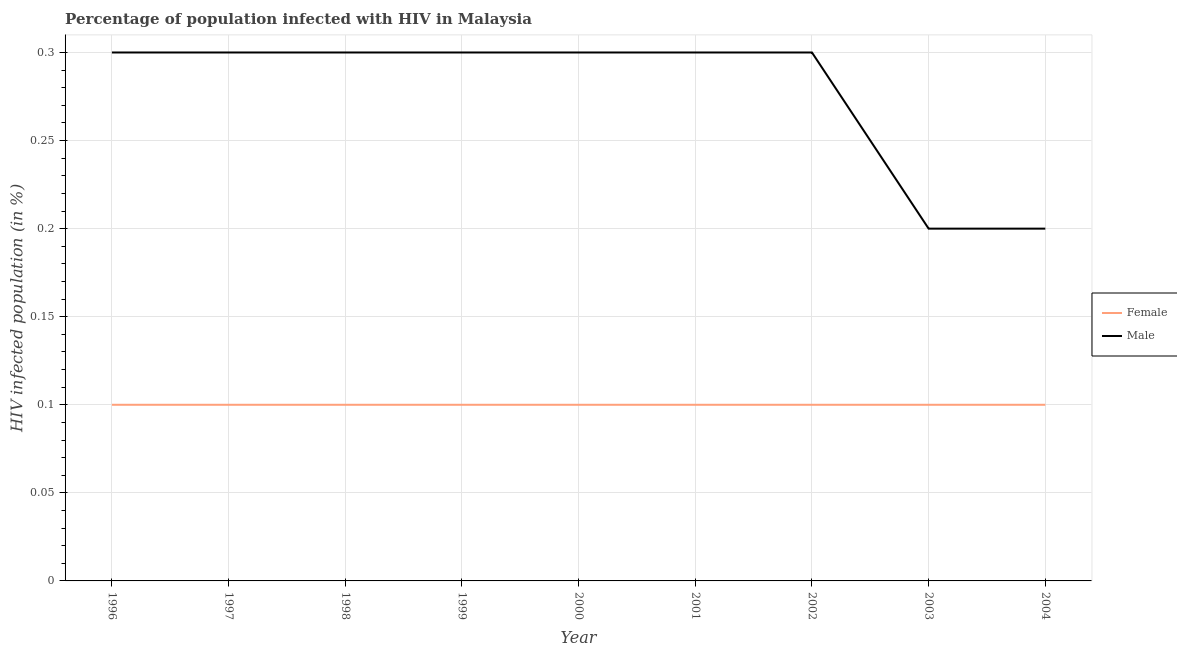How many different coloured lines are there?
Offer a terse response. 2. Across all years, what is the maximum percentage of males who are infected with hiv?
Keep it short and to the point. 0.3. What is the difference between the percentage of females who are infected with hiv in 1999 and that in 2002?
Provide a succinct answer. 0. What is the difference between the percentage of females who are infected with hiv in 1999 and the percentage of males who are infected with hiv in 2001?
Ensure brevity in your answer.  -0.2. What is the average percentage of females who are infected with hiv per year?
Provide a succinct answer. 0.1. In the year 2003, what is the difference between the percentage of females who are infected with hiv and percentage of males who are infected with hiv?
Offer a very short reply. -0.1. What is the ratio of the percentage of males who are infected with hiv in 2001 to that in 2004?
Give a very brief answer. 1.5. What is the difference between the highest and the second highest percentage of males who are infected with hiv?
Your answer should be very brief. 0. What is the difference between the highest and the lowest percentage of males who are infected with hiv?
Give a very brief answer. 0.1. In how many years, is the percentage of males who are infected with hiv greater than the average percentage of males who are infected with hiv taken over all years?
Offer a very short reply. 7. Is the sum of the percentage of females who are infected with hiv in 2001 and 2002 greater than the maximum percentage of males who are infected with hiv across all years?
Your response must be concise. No. Does the percentage of males who are infected with hiv monotonically increase over the years?
Offer a very short reply. No. Is the percentage of males who are infected with hiv strictly greater than the percentage of females who are infected with hiv over the years?
Your answer should be very brief. Yes. Is the percentage of males who are infected with hiv strictly less than the percentage of females who are infected with hiv over the years?
Offer a terse response. No. What is the difference between two consecutive major ticks on the Y-axis?
Give a very brief answer. 0.05. Are the values on the major ticks of Y-axis written in scientific E-notation?
Offer a very short reply. No. Does the graph contain any zero values?
Ensure brevity in your answer.  No. Does the graph contain grids?
Make the answer very short. Yes. What is the title of the graph?
Offer a terse response. Percentage of population infected with HIV in Malaysia. Does "Non-resident workers" appear as one of the legend labels in the graph?
Provide a succinct answer. No. What is the label or title of the Y-axis?
Ensure brevity in your answer.  HIV infected population (in %). What is the HIV infected population (in %) of Male in 1996?
Provide a short and direct response. 0.3. What is the HIV infected population (in %) of Female in 1999?
Your answer should be very brief. 0.1. What is the HIV infected population (in %) of Male in 1999?
Offer a very short reply. 0.3. What is the HIV infected population (in %) in Male in 2000?
Provide a short and direct response. 0.3. What is the HIV infected population (in %) of Female in 2001?
Ensure brevity in your answer.  0.1. What is the HIV infected population (in %) of Male in 2001?
Your response must be concise. 0.3. What is the HIV infected population (in %) in Female in 2002?
Give a very brief answer. 0.1. What is the HIV infected population (in %) of Female in 2003?
Give a very brief answer. 0.1. What is the HIV infected population (in %) in Male in 2003?
Make the answer very short. 0.2. What is the HIV infected population (in %) of Female in 2004?
Ensure brevity in your answer.  0.1. Across all years, what is the maximum HIV infected population (in %) in Male?
Offer a terse response. 0.3. Across all years, what is the minimum HIV infected population (in %) in Male?
Keep it short and to the point. 0.2. What is the total HIV infected population (in %) of Female in the graph?
Provide a short and direct response. 0.9. What is the difference between the HIV infected population (in %) in Female in 1996 and that in 1997?
Your response must be concise. 0. What is the difference between the HIV infected population (in %) in Female in 1996 and that in 1999?
Make the answer very short. 0. What is the difference between the HIV infected population (in %) in Male in 1996 and that in 2000?
Provide a short and direct response. 0. What is the difference between the HIV infected population (in %) in Male in 1996 and that in 2001?
Offer a terse response. 0. What is the difference between the HIV infected population (in %) in Female in 1996 and that in 2002?
Keep it short and to the point. 0. What is the difference between the HIV infected population (in %) of Male in 1996 and that in 2003?
Keep it short and to the point. 0.1. What is the difference between the HIV infected population (in %) of Male in 1996 and that in 2004?
Your answer should be very brief. 0.1. What is the difference between the HIV infected population (in %) in Female in 1997 and that in 1998?
Provide a succinct answer. 0. What is the difference between the HIV infected population (in %) of Male in 1997 and that in 1998?
Your answer should be compact. 0. What is the difference between the HIV infected population (in %) of Male in 1997 and that in 2000?
Your response must be concise. 0. What is the difference between the HIV infected population (in %) of Female in 1997 and that in 2001?
Your answer should be very brief. 0. What is the difference between the HIV infected population (in %) of Female in 1997 and that in 2003?
Make the answer very short. 0. What is the difference between the HIV infected population (in %) in Male in 1997 and that in 2003?
Provide a short and direct response. 0.1. What is the difference between the HIV infected population (in %) in Female in 1998 and that in 2000?
Ensure brevity in your answer.  0. What is the difference between the HIV infected population (in %) of Male in 1998 and that in 2002?
Provide a short and direct response. 0. What is the difference between the HIV infected population (in %) in Female in 1998 and that in 2004?
Offer a terse response. 0. What is the difference between the HIV infected population (in %) of Male in 1998 and that in 2004?
Provide a succinct answer. 0.1. What is the difference between the HIV infected population (in %) in Male in 1999 and that in 2000?
Offer a terse response. 0. What is the difference between the HIV infected population (in %) of Male in 1999 and that in 2001?
Your response must be concise. 0. What is the difference between the HIV infected population (in %) of Male in 1999 and that in 2003?
Keep it short and to the point. 0.1. What is the difference between the HIV infected population (in %) in Female in 1999 and that in 2004?
Your answer should be compact. 0. What is the difference between the HIV infected population (in %) in Male in 2000 and that in 2002?
Offer a terse response. 0. What is the difference between the HIV infected population (in %) in Male in 2000 and that in 2003?
Provide a succinct answer. 0.1. What is the difference between the HIV infected population (in %) in Female in 2000 and that in 2004?
Your answer should be very brief. 0. What is the difference between the HIV infected population (in %) in Male in 2000 and that in 2004?
Make the answer very short. 0.1. What is the difference between the HIV infected population (in %) of Female in 2001 and that in 2002?
Offer a very short reply. 0. What is the difference between the HIV infected population (in %) in Male in 2001 and that in 2002?
Provide a short and direct response. 0. What is the difference between the HIV infected population (in %) in Male in 2002 and that in 2003?
Your response must be concise. 0.1. What is the difference between the HIV infected population (in %) in Female in 2002 and that in 2004?
Offer a terse response. 0. What is the difference between the HIV infected population (in %) in Male in 2003 and that in 2004?
Ensure brevity in your answer.  0. What is the difference between the HIV infected population (in %) in Female in 1996 and the HIV infected population (in %) in Male in 2001?
Offer a very short reply. -0.2. What is the difference between the HIV infected population (in %) in Female in 1997 and the HIV infected population (in %) in Male in 2000?
Ensure brevity in your answer.  -0.2. What is the difference between the HIV infected population (in %) in Female in 1997 and the HIV infected population (in %) in Male in 2004?
Offer a terse response. -0.1. What is the difference between the HIV infected population (in %) in Female in 1998 and the HIV infected population (in %) in Male in 2000?
Your answer should be very brief. -0.2. What is the difference between the HIV infected population (in %) of Female in 1998 and the HIV infected population (in %) of Male in 2001?
Keep it short and to the point. -0.2. What is the difference between the HIV infected population (in %) of Female in 1998 and the HIV infected population (in %) of Male in 2002?
Ensure brevity in your answer.  -0.2. What is the difference between the HIV infected population (in %) of Female in 1998 and the HIV infected population (in %) of Male in 2003?
Provide a short and direct response. -0.1. What is the difference between the HIV infected population (in %) in Female in 1999 and the HIV infected population (in %) in Male in 2000?
Provide a succinct answer. -0.2. What is the difference between the HIV infected population (in %) of Female in 1999 and the HIV infected population (in %) of Male in 2004?
Offer a terse response. -0.1. What is the difference between the HIV infected population (in %) of Female in 2000 and the HIV infected population (in %) of Male in 2002?
Provide a succinct answer. -0.2. What is the difference between the HIV infected population (in %) of Female in 2000 and the HIV infected population (in %) of Male in 2004?
Ensure brevity in your answer.  -0.1. What is the difference between the HIV infected population (in %) of Female in 2001 and the HIV infected population (in %) of Male in 2002?
Offer a terse response. -0.2. What is the difference between the HIV infected population (in %) in Female in 2001 and the HIV infected population (in %) in Male in 2003?
Provide a short and direct response. -0.1. What is the difference between the HIV infected population (in %) in Female in 2001 and the HIV infected population (in %) in Male in 2004?
Your response must be concise. -0.1. What is the difference between the HIV infected population (in %) in Female in 2002 and the HIV infected population (in %) in Male in 2003?
Keep it short and to the point. -0.1. What is the difference between the HIV infected population (in %) of Female in 2003 and the HIV infected population (in %) of Male in 2004?
Your answer should be very brief. -0.1. What is the average HIV infected population (in %) of Male per year?
Ensure brevity in your answer.  0.28. In the year 1996, what is the difference between the HIV infected population (in %) of Female and HIV infected population (in %) of Male?
Make the answer very short. -0.2. In the year 1999, what is the difference between the HIV infected population (in %) in Female and HIV infected population (in %) in Male?
Your response must be concise. -0.2. In the year 2003, what is the difference between the HIV infected population (in %) in Female and HIV infected population (in %) in Male?
Keep it short and to the point. -0.1. In the year 2004, what is the difference between the HIV infected population (in %) of Female and HIV infected population (in %) of Male?
Your answer should be very brief. -0.1. What is the ratio of the HIV infected population (in %) of Female in 1996 to that in 1997?
Offer a terse response. 1. What is the ratio of the HIV infected population (in %) of Male in 1996 to that in 1998?
Give a very brief answer. 1. What is the ratio of the HIV infected population (in %) of Male in 1996 to that in 1999?
Provide a succinct answer. 1. What is the ratio of the HIV infected population (in %) of Female in 1996 to that in 2000?
Offer a very short reply. 1. What is the ratio of the HIV infected population (in %) of Male in 1996 to that in 2000?
Make the answer very short. 1. What is the ratio of the HIV infected population (in %) of Male in 1996 to that in 2001?
Give a very brief answer. 1. What is the ratio of the HIV infected population (in %) in Female in 1996 to that in 2003?
Your response must be concise. 1. What is the ratio of the HIV infected population (in %) of Male in 1997 to that in 1998?
Make the answer very short. 1. What is the ratio of the HIV infected population (in %) in Female in 1997 to that in 1999?
Your answer should be compact. 1. What is the ratio of the HIV infected population (in %) of Male in 1997 to that in 1999?
Keep it short and to the point. 1. What is the ratio of the HIV infected population (in %) in Male in 1997 to that in 2000?
Make the answer very short. 1. What is the ratio of the HIV infected population (in %) of Female in 1997 to that in 2001?
Your answer should be compact. 1. What is the ratio of the HIV infected population (in %) of Female in 1997 to that in 2002?
Your answer should be compact. 1. What is the ratio of the HIV infected population (in %) in Male in 1997 to that in 2002?
Keep it short and to the point. 1. What is the ratio of the HIV infected population (in %) of Female in 1998 to that in 2002?
Offer a terse response. 1. What is the ratio of the HIV infected population (in %) of Male in 1998 to that in 2002?
Your response must be concise. 1. What is the ratio of the HIV infected population (in %) in Male in 1998 to that in 2003?
Offer a terse response. 1.5. What is the ratio of the HIV infected population (in %) in Female in 1998 to that in 2004?
Give a very brief answer. 1. What is the ratio of the HIV infected population (in %) in Female in 1999 to that in 2000?
Your answer should be compact. 1. What is the ratio of the HIV infected population (in %) of Male in 1999 to that in 2002?
Your response must be concise. 1. What is the ratio of the HIV infected population (in %) of Female in 1999 to that in 2003?
Your answer should be compact. 1. What is the ratio of the HIV infected population (in %) of Male in 1999 to that in 2003?
Keep it short and to the point. 1.5. What is the ratio of the HIV infected population (in %) in Female in 1999 to that in 2004?
Give a very brief answer. 1. What is the ratio of the HIV infected population (in %) of Female in 2000 to that in 2001?
Keep it short and to the point. 1. What is the ratio of the HIV infected population (in %) of Male in 2000 to that in 2001?
Provide a short and direct response. 1. What is the ratio of the HIV infected population (in %) in Male in 2000 to that in 2002?
Your answer should be very brief. 1. What is the ratio of the HIV infected population (in %) of Female in 2000 to that in 2003?
Keep it short and to the point. 1. What is the ratio of the HIV infected population (in %) in Male in 2000 to that in 2003?
Offer a terse response. 1.5. What is the ratio of the HIV infected population (in %) in Female in 2001 to that in 2002?
Your answer should be compact. 1. What is the ratio of the HIV infected population (in %) in Male in 2001 to that in 2002?
Keep it short and to the point. 1. What is the ratio of the HIV infected population (in %) in Male in 2001 to that in 2004?
Offer a terse response. 1.5. What is the ratio of the HIV infected population (in %) of Female in 2002 to that in 2003?
Give a very brief answer. 1. What is the ratio of the HIV infected population (in %) in Male in 2002 to that in 2003?
Offer a terse response. 1.5. What is the ratio of the HIV infected population (in %) in Male in 2002 to that in 2004?
Offer a terse response. 1.5. What is the ratio of the HIV infected population (in %) in Female in 2003 to that in 2004?
Keep it short and to the point. 1. What is the ratio of the HIV infected population (in %) in Male in 2003 to that in 2004?
Your response must be concise. 1. What is the difference between the highest and the second highest HIV infected population (in %) in Male?
Ensure brevity in your answer.  0. What is the difference between the highest and the lowest HIV infected population (in %) of Female?
Offer a very short reply. 0. 